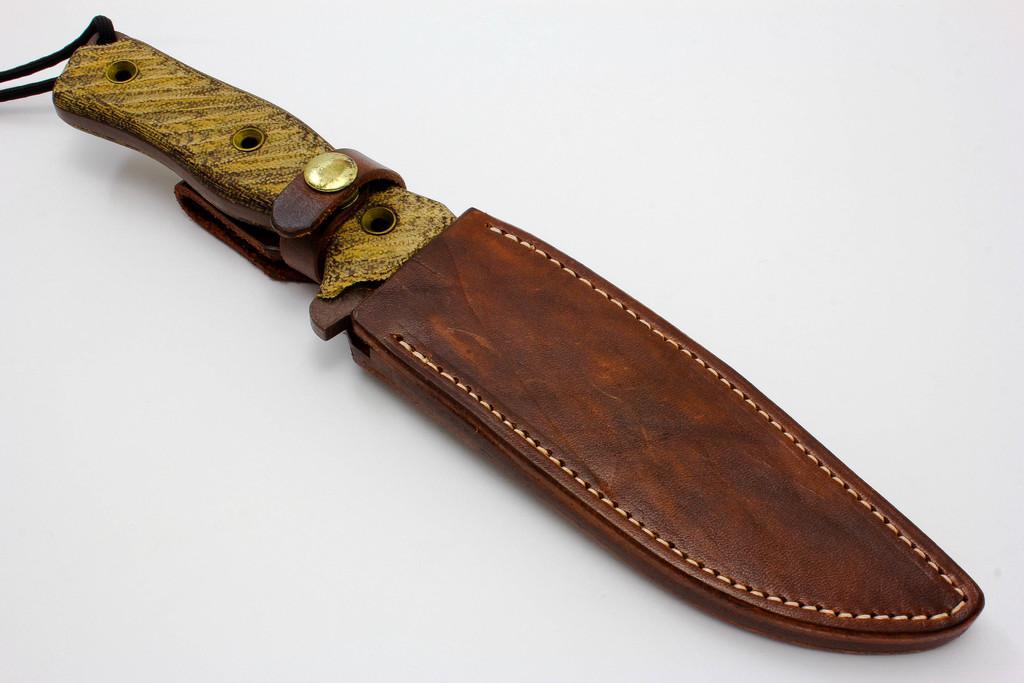How would you summarize this image in a sentence or two? In this picture there is a knife on the table. 